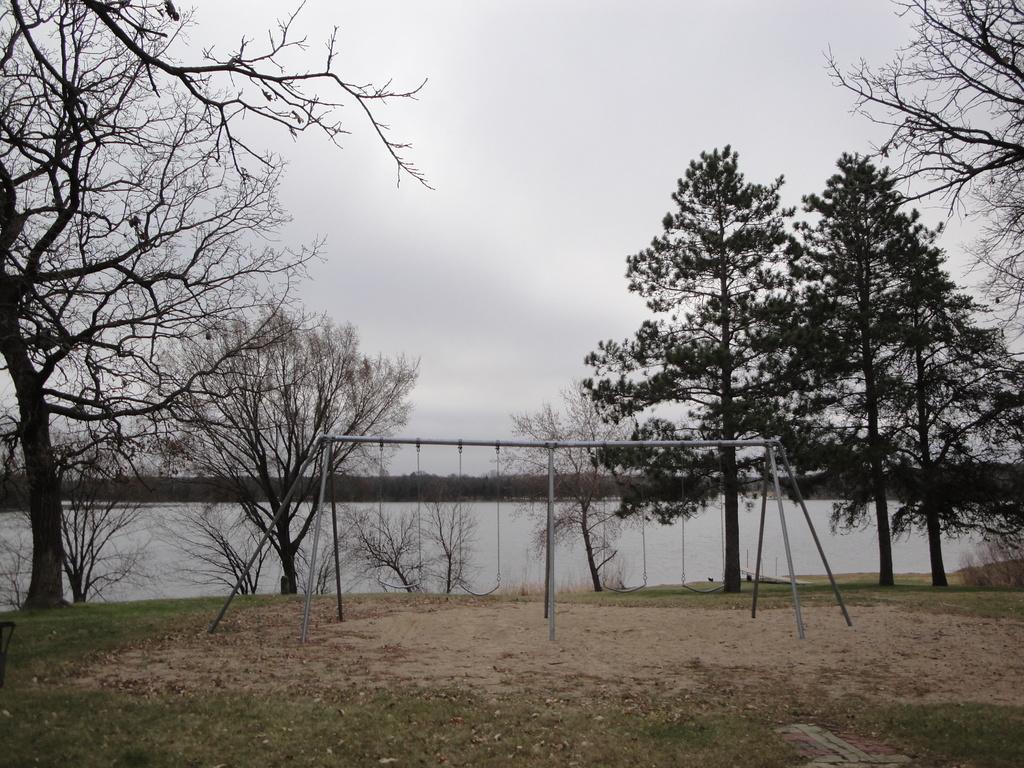How would you summarize this image in a sentence or two? In this image we can see there are swings, behind the swings there are trees, river and a sky. 